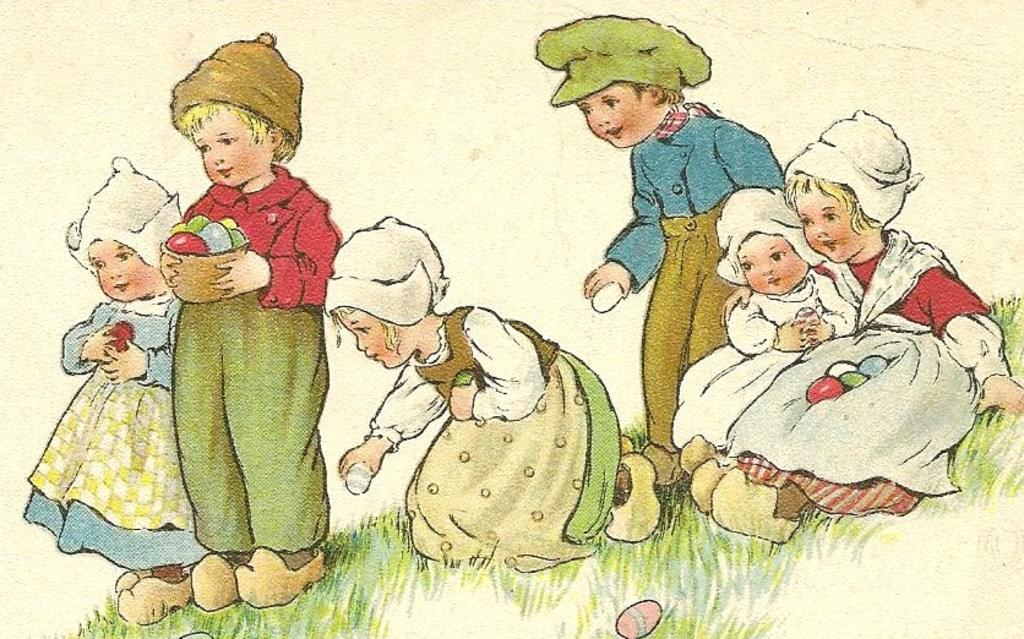What is the main subject of the image? There is a painting in the image. What is depicted in the painting? The painting depicts grass and kids. What are the kids doing in the painting? One of the kids is holding a bowl with his hands. What type of worm can be seen crawling on the grass in the painting? There is no worm present in the painting; it depicts grass and kids. How many books are visible in the painting? There are no books visible in the painting; it only shows grass and kids. 